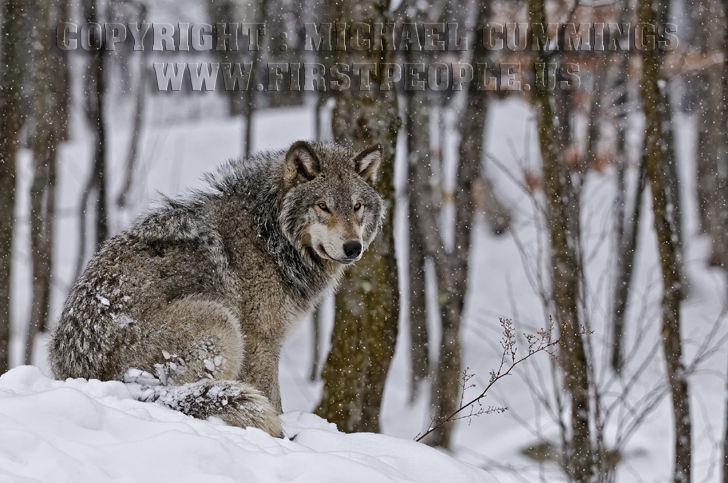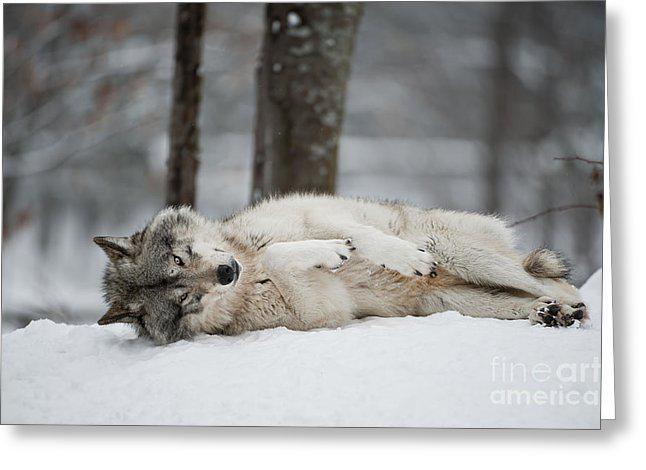The first image is the image on the left, the second image is the image on the right. Analyze the images presented: Is the assertion "Each image contains exactly one wolf, and all wolves shown are upright instead of reclining." valid? Answer yes or no. No. The first image is the image on the left, the second image is the image on the right. For the images displayed, is the sentence "At least one wolf is sitting." factually correct? Answer yes or no. Yes. 